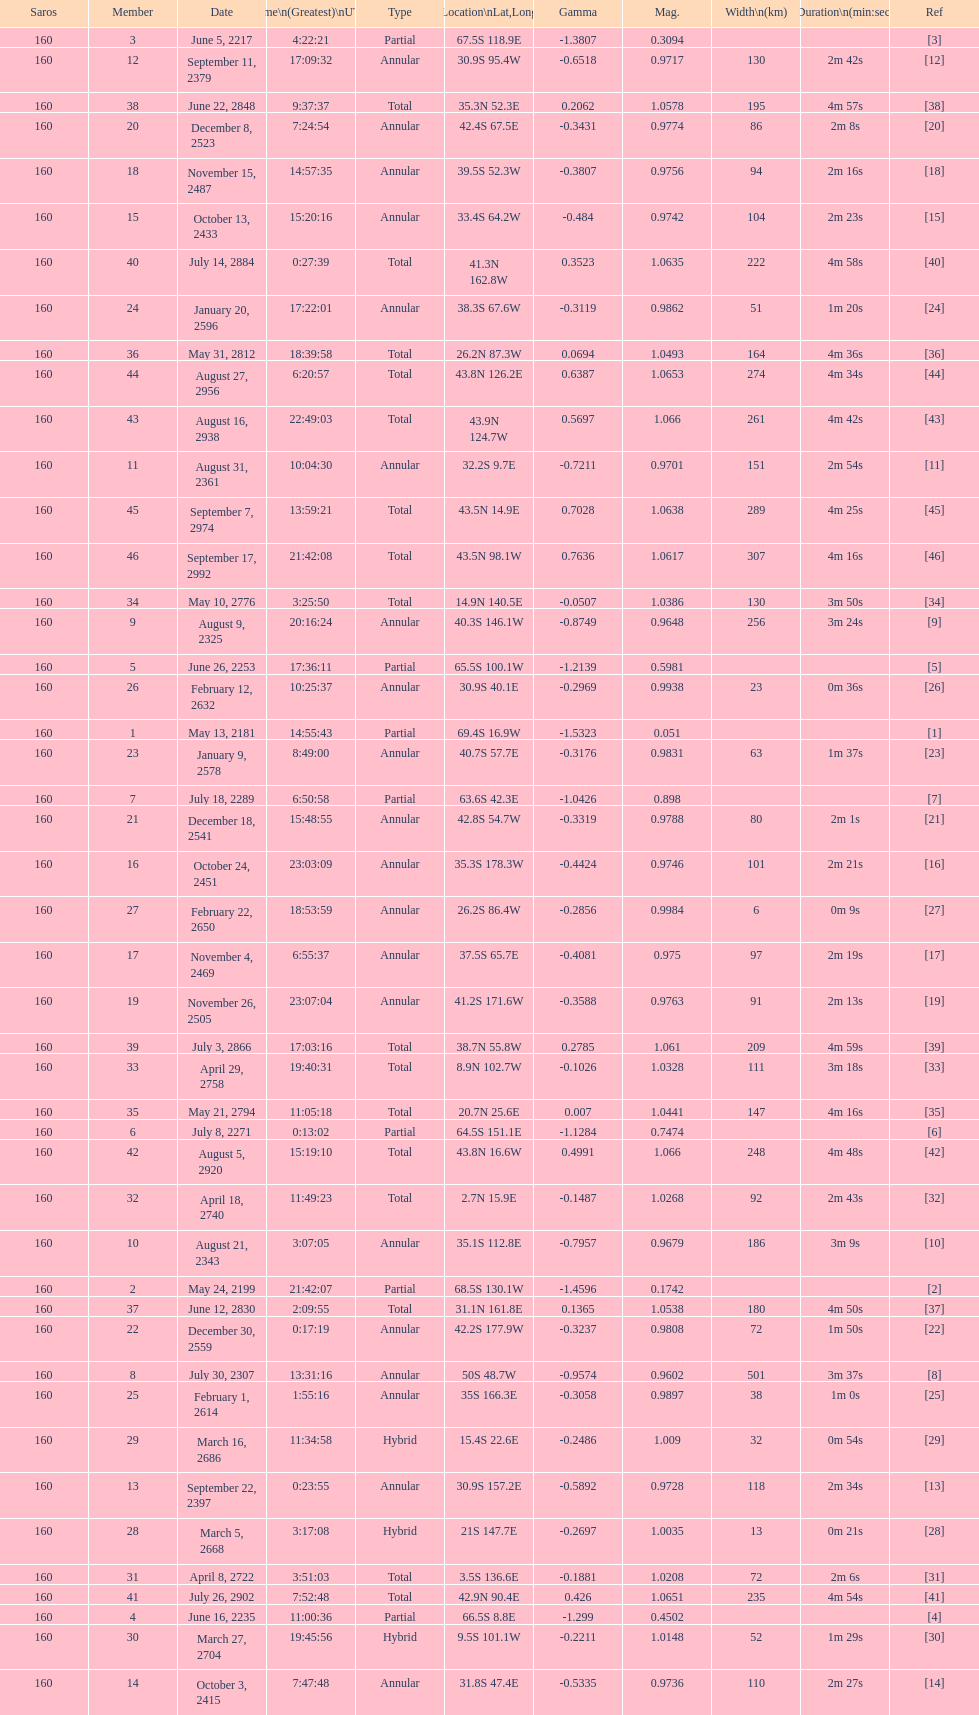How many solar saros occurrences had a duration exceeding 4 minutes? 12. Would you mind parsing the complete table? {'header': ['Saros', 'Member', 'Date', 'Time\\n(Greatest)\\nUTC', 'Type', 'Location\\nLat,Long', 'Gamma', 'Mag.', 'Width\\n(km)', 'Duration\\n(min:sec)', 'Ref'], 'rows': [['160', '3', 'June 5, 2217', '4:22:21', 'Partial', '67.5S 118.9E', '-1.3807', '0.3094', '', '', '[3]'], ['160', '12', 'September 11, 2379', '17:09:32', 'Annular', '30.9S 95.4W', '-0.6518', '0.9717', '130', '2m 42s', '[12]'], ['160', '38', 'June 22, 2848', '9:37:37', 'Total', '35.3N 52.3E', '0.2062', '1.0578', '195', '4m 57s', '[38]'], ['160', '20', 'December 8, 2523', '7:24:54', 'Annular', '42.4S 67.5E', '-0.3431', '0.9774', '86', '2m 8s', '[20]'], ['160', '18', 'November 15, 2487', '14:57:35', 'Annular', '39.5S 52.3W', '-0.3807', '0.9756', '94', '2m 16s', '[18]'], ['160', '15', 'October 13, 2433', '15:20:16', 'Annular', '33.4S 64.2W', '-0.484', '0.9742', '104', '2m 23s', '[15]'], ['160', '40', 'July 14, 2884', '0:27:39', 'Total', '41.3N 162.8W', '0.3523', '1.0635', '222', '4m 58s', '[40]'], ['160', '24', 'January 20, 2596', '17:22:01', 'Annular', '38.3S 67.6W', '-0.3119', '0.9862', '51', '1m 20s', '[24]'], ['160', '36', 'May 31, 2812', '18:39:58', 'Total', '26.2N 87.3W', '0.0694', '1.0493', '164', '4m 36s', '[36]'], ['160', '44', 'August 27, 2956', '6:20:57', 'Total', '43.8N 126.2E', '0.6387', '1.0653', '274', '4m 34s', '[44]'], ['160', '43', 'August 16, 2938', '22:49:03', 'Total', '43.9N 124.7W', '0.5697', '1.066', '261', '4m 42s', '[43]'], ['160', '11', 'August 31, 2361', '10:04:30', 'Annular', '32.2S 9.7E', '-0.7211', '0.9701', '151', '2m 54s', '[11]'], ['160', '45', 'September 7, 2974', '13:59:21', 'Total', '43.5N 14.9E', '0.7028', '1.0638', '289', '4m 25s', '[45]'], ['160', '46', 'September 17, 2992', '21:42:08', 'Total', '43.5N 98.1W', '0.7636', '1.0617', '307', '4m 16s', '[46]'], ['160', '34', 'May 10, 2776', '3:25:50', 'Total', '14.9N 140.5E', '-0.0507', '1.0386', '130', '3m 50s', '[34]'], ['160', '9', 'August 9, 2325', '20:16:24', 'Annular', '40.3S 146.1W', '-0.8749', '0.9648', '256', '3m 24s', '[9]'], ['160', '5', 'June 26, 2253', '17:36:11', 'Partial', '65.5S 100.1W', '-1.2139', '0.5981', '', '', '[5]'], ['160', '26', 'February 12, 2632', '10:25:37', 'Annular', '30.9S 40.1E', '-0.2969', '0.9938', '23', '0m 36s', '[26]'], ['160', '1', 'May 13, 2181', '14:55:43', 'Partial', '69.4S 16.9W', '-1.5323', '0.051', '', '', '[1]'], ['160', '23', 'January 9, 2578', '8:49:00', 'Annular', '40.7S 57.7E', '-0.3176', '0.9831', '63', '1m 37s', '[23]'], ['160', '7', 'July 18, 2289', '6:50:58', 'Partial', '63.6S 42.3E', '-1.0426', '0.898', '', '', '[7]'], ['160', '21', 'December 18, 2541', '15:48:55', 'Annular', '42.8S 54.7W', '-0.3319', '0.9788', '80', '2m 1s', '[21]'], ['160', '16', 'October 24, 2451', '23:03:09', 'Annular', '35.3S 178.3W', '-0.4424', '0.9746', '101', '2m 21s', '[16]'], ['160', '27', 'February 22, 2650', '18:53:59', 'Annular', '26.2S 86.4W', '-0.2856', '0.9984', '6', '0m 9s', '[27]'], ['160', '17', 'November 4, 2469', '6:55:37', 'Annular', '37.5S 65.7E', '-0.4081', '0.975', '97', '2m 19s', '[17]'], ['160', '19', 'November 26, 2505', '23:07:04', 'Annular', '41.2S 171.6W', '-0.3588', '0.9763', '91', '2m 13s', '[19]'], ['160', '39', 'July 3, 2866', '17:03:16', 'Total', '38.7N 55.8W', '0.2785', '1.061', '209', '4m 59s', '[39]'], ['160', '33', 'April 29, 2758', '19:40:31', 'Total', '8.9N 102.7W', '-0.1026', '1.0328', '111', '3m 18s', '[33]'], ['160', '35', 'May 21, 2794', '11:05:18', 'Total', '20.7N 25.6E', '0.007', '1.0441', '147', '4m 16s', '[35]'], ['160', '6', 'July 8, 2271', '0:13:02', 'Partial', '64.5S 151.1E', '-1.1284', '0.7474', '', '', '[6]'], ['160', '42', 'August 5, 2920', '15:19:10', 'Total', '43.8N 16.6W', '0.4991', '1.066', '248', '4m 48s', '[42]'], ['160', '32', 'April 18, 2740', '11:49:23', 'Total', '2.7N 15.9E', '-0.1487', '1.0268', '92', '2m 43s', '[32]'], ['160', '10', 'August 21, 2343', '3:07:05', 'Annular', '35.1S 112.8E', '-0.7957', '0.9679', '186', '3m 9s', '[10]'], ['160', '2', 'May 24, 2199', '21:42:07', 'Partial', '68.5S 130.1W', '-1.4596', '0.1742', '', '', '[2]'], ['160', '37', 'June 12, 2830', '2:09:55', 'Total', '31.1N 161.8E', '0.1365', '1.0538', '180', '4m 50s', '[37]'], ['160', '22', 'December 30, 2559', '0:17:19', 'Annular', '42.2S 177.9W', '-0.3237', '0.9808', '72', '1m 50s', '[22]'], ['160', '8', 'July 30, 2307', '13:31:16', 'Annular', '50S 48.7W', '-0.9574', '0.9602', '501', '3m 37s', '[8]'], ['160', '25', 'February 1, 2614', '1:55:16', 'Annular', '35S 166.3E', '-0.3058', '0.9897', '38', '1m 0s', '[25]'], ['160', '29', 'March 16, 2686', '11:34:58', 'Hybrid', '15.4S 22.6E', '-0.2486', '1.009', '32', '0m 54s', '[29]'], ['160', '13', 'September 22, 2397', '0:23:55', 'Annular', '30.9S 157.2E', '-0.5892', '0.9728', '118', '2m 34s', '[13]'], ['160', '28', 'March 5, 2668', '3:17:08', 'Hybrid', '21S 147.7E', '-0.2697', '1.0035', '13', '0m 21s', '[28]'], ['160', '31', 'April 8, 2722', '3:51:03', 'Total', '3.5S 136.6E', '-0.1881', '1.0208', '72', '2m 6s', '[31]'], ['160', '41', 'July 26, 2902', '7:52:48', 'Total', '42.9N 90.4E', '0.426', '1.0651', '235', '4m 54s', '[41]'], ['160', '4', 'June 16, 2235', '11:00:36', 'Partial', '66.5S 8.8E', '-1.299', '0.4502', '', '', '[4]'], ['160', '30', 'March 27, 2704', '19:45:56', 'Hybrid', '9.5S 101.1W', '-0.2211', '1.0148', '52', '1m 29s', '[30]'], ['160', '14', 'October 3, 2415', '7:47:48', 'Annular', '31.8S 47.4E', '-0.5335', '0.9736', '110', '2m 27s', '[14]']]} 